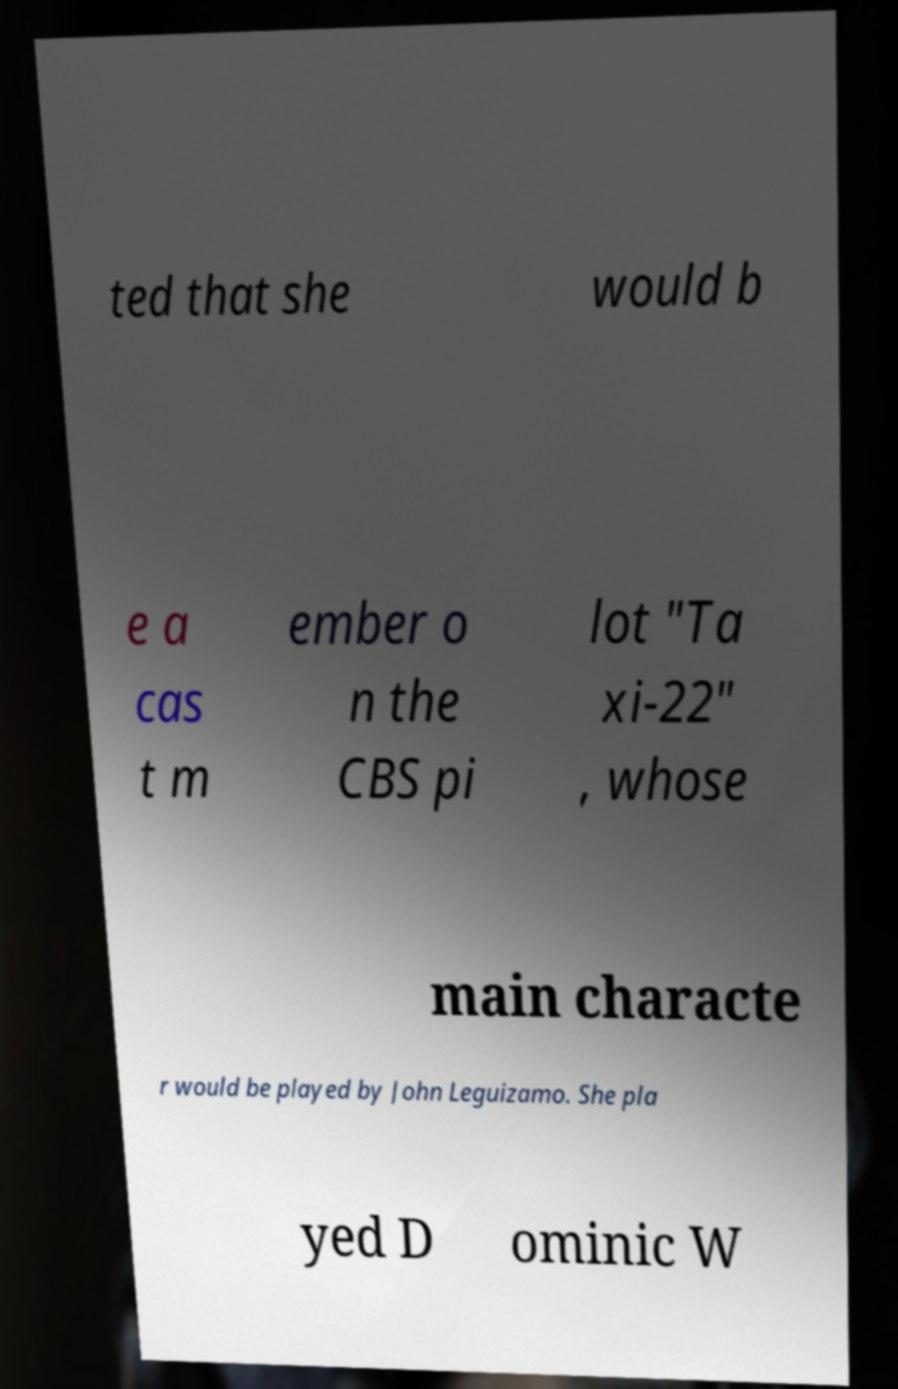What messages or text are displayed in this image? I need them in a readable, typed format. ted that she would b e a cas t m ember o n the CBS pi lot "Ta xi-22" , whose main characte r would be played by John Leguizamo. She pla yed D ominic W 